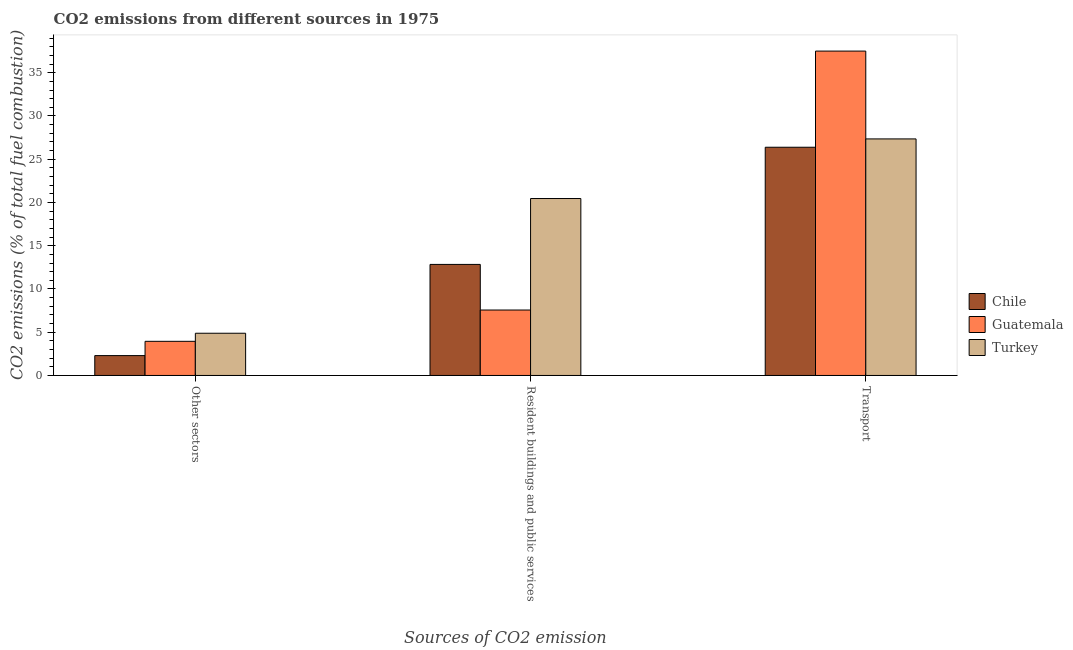Are the number of bars per tick equal to the number of legend labels?
Your answer should be very brief. Yes. Are the number of bars on each tick of the X-axis equal?
Offer a very short reply. Yes. How many bars are there on the 2nd tick from the left?
Give a very brief answer. 3. How many bars are there on the 2nd tick from the right?
Keep it short and to the point. 3. What is the label of the 3rd group of bars from the left?
Your answer should be compact. Transport. What is the percentage of co2 emissions from other sectors in Chile?
Keep it short and to the point. 2.3. Across all countries, what is the maximum percentage of co2 emissions from other sectors?
Keep it short and to the point. 4.88. Across all countries, what is the minimum percentage of co2 emissions from resident buildings and public services?
Give a very brief answer. 7.57. In which country was the percentage of co2 emissions from transport maximum?
Give a very brief answer. Guatemala. In which country was the percentage of co2 emissions from resident buildings and public services minimum?
Offer a terse response. Guatemala. What is the total percentage of co2 emissions from resident buildings and public services in the graph?
Make the answer very short. 40.86. What is the difference between the percentage of co2 emissions from transport in Turkey and that in Chile?
Make the answer very short. 0.96. What is the difference between the percentage of co2 emissions from resident buildings and public services in Guatemala and the percentage of co2 emissions from transport in Chile?
Give a very brief answer. -18.82. What is the average percentage of co2 emissions from transport per country?
Your answer should be very brief. 30.41. What is the difference between the percentage of co2 emissions from resident buildings and public services and percentage of co2 emissions from transport in Chile?
Keep it short and to the point. -13.55. What is the ratio of the percentage of co2 emissions from transport in Turkey to that in Chile?
Offer a terse response. 1.04. Is the percentage of co2 emissions from other sectors in Guatemala less than that in Chile?
Give a very brief answer. No. Is the difference between the percentage of co2 emissions from transport in Guatemala and Chile greater than the difference between the percentage of co2 emissions from resident buildings and public services in Guatemala and Chile?
Your answer should be very brief. Yes. What is the difference between the highest and the second highest percentage of co2 emissions from resident buildings and public services?
Provide a succinct answer. 7.62. What is the difference between the highest and the lowest percentage of co2 emissions from other sectors?
Offer a terse response. 2.58. What does the 2nd bar from the left in Resident buildings and public services represents?
Make the answer very short. Guatemala. Is it the case that in every country, the sum of the percentage of co2 emissions from other sectors and percentage of co2 emissions from resident buildings and public services is greater than the percentage of co2 emissions from transport?
Your answer should be very brief. No. How many bars are there?
Ensure brevity in your answer.  9. Are all the bars in the graph horizontal?
Ensure brevity in your answer.  No. How many countries are there in the graph?
Keep it short and to the point. 3. What is the difference between two consecutive major ticks on the Y-axis?
Offer a terse response. 5. Are the values on the major ticks of Y-axis written in scientific E-notation?
Your answer should be very brief. No. Does the graph contain any zero values?
Make the answer very short. No. Does the graph contain grids?
Offer a very short reply. No. Where does the legend appear in the graph?
Your answer should be compact. Center right. How are the legend labels stacked?
Ensure brevity in your answer.  Vertical. What is the title of the graph?
Make the answer very short. CO2 emissions from different sources in 1975. What is the label or title of the X-axis?
Give a very brief answer. Sources of CO2 emission. What is the label or title of the Y-axis?
Your response must be concise. CO2 emissions (% of total fuel combustion). What is the CO2 emissions (% of total fuel combustion) in Chile in Other sectors?
Offer a terse response. 2.3. What is the CO2 emissions (% of total fuel combustion) in Guatemala in Other sectors?
Ensure brevity in your answer.  3.95. What is the CO2 emissions (% of total fuel combustion) in Turkey in Other sectors?
Your answer should be compact. 4.88. What is the CO2 emissions (% of total fuel combustion) of Chile in Resident buildings and public services?
Ensure brevity in your answer.  12.84. What is the CO2 emissions (% of total fuel combustion) of Guatemala in Resident buildings and public services?
Your answer should be very brief. 7.57. What is the CO2 emissions (% of total fuel combustion) in Turkey in Resident buildings and public services?
Offer a terse response. 20.46. What is the CO2 emissions (% of total fuel combustion) of Chile in Transport?
Provide a succinct answer. 26.38. What is the CO2 emissions (% of total fuel combustion) in Guatemala in Transport?
Ensure brevity in your answer.  37.5. What is the CO2 emissions (% of total fuel combustion) of Turkey in Transport?
Provide a succinct answer. 27.35. Across all Sources of CO2 emission, what is the maximum CO2 emissions (% of total fuel combustion) in Chile?
Keep it short and to the point. 26.38. Across all Sources of CO2 emission, what is the maximum CO2 emissions (% of total fuel combustion) in Guatemala?
Offer a terse response. 37.5. Across all Sources of CO2 emission, what is the maximum CO2 emissions (% of total fuel combustion) of Turkey?
Give a very brief answer. 27.35. Across all Sources of CO2 emission, what is the minimum CO2 emissions (% of total fuel combustion) in Chile?
Make the answer very short. 2.3. Across all Sources of CO2 emission, what is the minimum CO2 emissions (% of total fuel combustion) of Guatemala?
Offer a terse response. 3.95. Across all Sources of CO2 emission, what is the minimum CO2 emissions (% of total fuel combustion) in Turkey?
Ensure brevity in your answer.  4.88. What is the total CO2 emissions (% of total fuel combustion) in Chile in the graph?
Give a very brief answer. 41.52. What is the total CO2 emissions (% of total fuel combustion) in Guatemala in the graph?
Make the answer very short. 49.01. What is the total CO2 emissions (% of total fuel combustion) of Turkey in the graph?
Make the answer very short. 52.69. What is the difference between the CO2 emissions (% of total fuel combustion) in Chile in Other sectors and that in Resident buildings and public services?
Give a very brief answer. -10.54. What is the difference between the CO2 emissions (% of total fuel combustion) of Guatemala in Other sectors and that in Resident buildings and public services?
Your response must be concise. -3.62. What is the difference between the CO2 emissions (% of total fuel combustion) of Turkey in Other sectors and that in Resident buildings and public services?
Your response must be concise. -15.57. What is the difference between the CO2 emissions (% of total fuel combustion) of Chile in Other sectors and that in Transport?
Offer a terse response. -24.09. What is the difference between the CO2 emissions (% of total fuel combustion) of Guatemala in Other sectors and that in Transport?
Keep it short and to the point. -33.55. What is the difference between the CO2 emissions (% of total fuel combustion) of Turkey in Other sectors and that in Transport?
Your answer should be very brief. -22.47. What is the difference between the CO2 emissions (% of total fuel combustion) of Chile in Resident buildings and public services and that in Transport?
Give a very brief answer. -13.55. What is the difference between the CO2 emissions (% of total fuel combustion) in Guatemala in Resident buildings and public services and that in Transport?
Your response must be concise. -29.93. What is the difference between the CO2 emissions (% of total fuel combustion) of Turkey in Resident buildings and public services and that in Transport?
Offer a very short reply. -6.89. What is the difference between the CO2 emissions (% of total fuel combustion) in Chile in Other sectors and the CO2 emissions (% of total fuel combustion) in Guatemala in Resident buildings and public services?
Give a very brief answer. -5.27. What is the difference between the CO2 emissions (% of total fuel combustion) in Chile in Other sectors and the CO2 emissions (% of total fuel combustion) in Turkey in Resident buildings and public services?
Provide a short and direct response. -18.16. What is the difference between the CO2 emissions (% of total fuel combustion) of Guatemala in Other sectors and the CO2 emissions (% of total fuel combustion) of Turkey in Resident buildings and public services?
Give a very brief answer. -16.51. What is the difference between the CO2 emissions (% of total fuel combustion) in Chile in Other sectors and the CO2 emissions (% of total fuel combustion) in Guatemala in Transport?
Keep it short and to the point. -35.2. What is the difference between the CO2 emissions (% of total fuel combustion) in Chile in Other sectors and the CO2 emissions (% of total fuel combustion) in Turkey in Transport?
Ensure brevity in your answer.  -25.05. What is the difference between the CO2 emissions (% of total fuel combustion) of Guatemala in Other sectors and the CO2 emissions (% of total fuel combustion) of Turkey in Transport?
Your answer should be very brief. -23.4. What is the difference between the CO2 emissions (% of total fuel combustion) of Chile in Resident buildings and public services and the CO2 emissions (% of total fuel combustion) of Guatemala in Transport?
Your response must be concise. -24.66. What is the difference between the CO2 emissions (% of total fuel combustion) in Chile in Resident buildings and public services and the CO2 emissions (% of total fuel combustion) in Turkey in Transport?
Offer a terse response. -14.51. What is the difference between the CO2 emissions (% of total fuel combustion) of Guatemala in Resident buildings and public services and the CO2 emissions (% of total fuel combustion) of Turkey in Transport?
Your response must be concise. -19.78. What is the average CO2 emissions (% of total fuel combustion) in Chile per Sources of CO2 emission?
Offer a terse response. 13.84. What is the average CO2 emissions (% of total fuel combustion) in Guatemala per Sources of CO2 emission?
Provide a succinct answer. 16.34. What is the average CO2 emissions (% of total fuel combustion) in Turkey per Sources of CO2 emission?
Your response must be concise. 17.56. What is the difference between the CO2 emissions (% of total fuel combustion) in Chile and CO2 emissions (% of total fuel combustion) in Guatemala in Other sectors?
Provide a succinct answer. -1.65. What is the difference between the CO2 emissions (% of total fuel combustion) in Chile and CO2 emissions (% of total fuel combustion) in Turkey in Other sectors?
Make the answer very short. -2.58. What is the difference between the CO2 emissions (% of total fuel combustion) in Guatemala and CO2 emissions (% of total fuel combustion) in Turkey in Other sectors?
Keep it short and to the point. -0.93. What is the difference between the CO2 emissions (% of total fuel combustion) of Chile and CO2 emissions (% of total fuel combustion) of Guatemala in Resident buildings and public services?
Ensure brevity in your answer.  5.27. What is the difference between the CO2 emissions (% of total fuel combustion) in Chile and CO2 emissions (% of total fuel combustion) in Turkey in Resident buildings and public services?
Provide a succinct answer. -7.62. What is the difference between the CO2 emissions (% of total fuel combustion) of Guatemala and CO2 emissions (% of total fuel combustion) of Turkey in Resident buildings and public services?
Provide a short and direct response. -12.89. What is the difference between the CO2 emissions (% of total fuel combustion) of Chile and CO2 emissions (% of total fuel combustion) of Guatemala in Transport?
Give a very brief answer. -11.12. What is the difference between the CO2 emissions (% of total fuel combustion) of Chile and CO2 emissions (% of total fuel combustion) of Turkey in Transport?
Make the answer very short. -0.96. What is the difference between the CO2 emissions (% of total fuel combustion) in Guatemala and CO2 emissions (% of total fuel combustion) in Turkey in Transport?
Provide a succinct answer. 10.15. What is the ratio of the CO2 emissions (% of total fuel combustion) in Chile in Other sectors to that in Resident buildings and public services?
Make the answer very short. 0.18. What is the ratio of the CO2 emissions (% of total fuel combustion) in Guatemala in Other sectors to that in Resident buildings and public services?
Make the answer very short. 0.52. What is the ratio of the CO2 emissions (% of total fuel combustion) of Turkey in Other sectors to that in Resident buildings and public services?
Offer a very short reply. 0.24. What is the ratio of the CO2 emissions (% of total fuel combustion) in Chile in Other sectors to that in Transport?
Your response must be concise. 0.09. What is the ratio of the CO2 emissions (% of total fuel combustion) of Guatemala in Other sectors to that in Transport?
Offer a terse response. 0.11. What is the ratio of the CO2 emissions (% of total fuel combustion) in Turkey in Other sectors to that in Transport?
Provide a short and direct response. 0.18. What is the ratio of the CO2 emissions (% of total fuel combustion) of Chile in Resident buildings and public services to that in Transport?
Keep it short and to the point. 0.49. What is the ratio of the CO2 emissions (% of total fuel combustion) of Guatemala in Resident buildings and public services to that in Transport?
Your answer should be compact. 0.2. What is the ratio of the CO2 emissions (% of total fuel combustion) of Turkey in Resident buildings and public services to that in Transport?
Give a very brief answer. 0.75. What is the difference between the highest and the second highest CO2 emissions (% of total fuel combustion) of Chile?
Offer a very short reply. 13.55. What is the difference between the highest and the second highest CO2 emissions (% of total fuel combustion) in Guatemala?
Give a very brief answer. 29.93. What is the difference between the highest and the second highest CO2 emissions (% of total fuel combustion) in Turkey?
Make the answer very short. 6.89. What is the difference between the highest and the lowest CO2 emissions (% of total fuel combustion) of Chile?
Offer a terse response. 24.09. What is the difference between the highest and the lowest CO2 emissions (% of total fuel combustion) of Guatemala?
Offer a terse response. 33.55. What is the difference between the highest and the lowest CO2 emissions (% of total fuel combustion) of Turkey?
Provide a short and direct response. 22.47. 